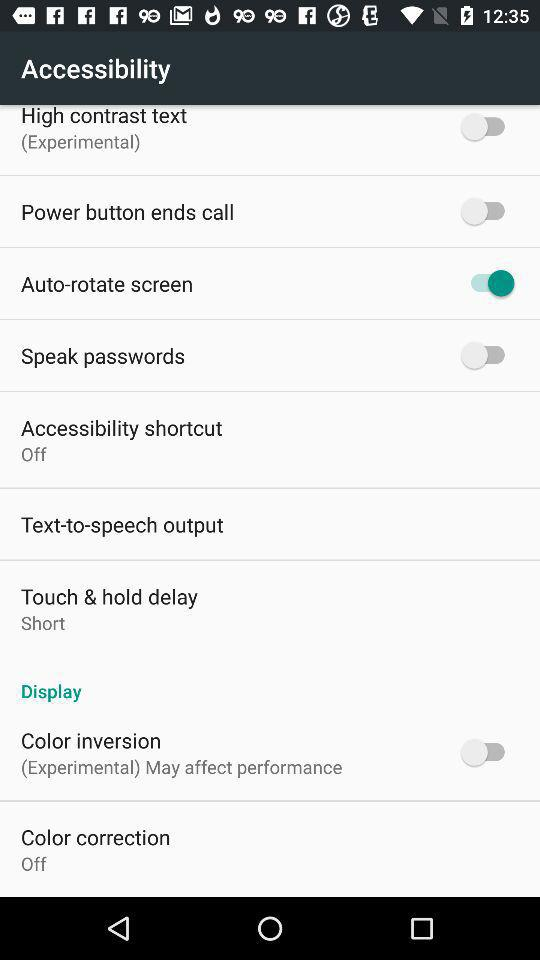What is the status of "Color inversion"? The status is "off". 